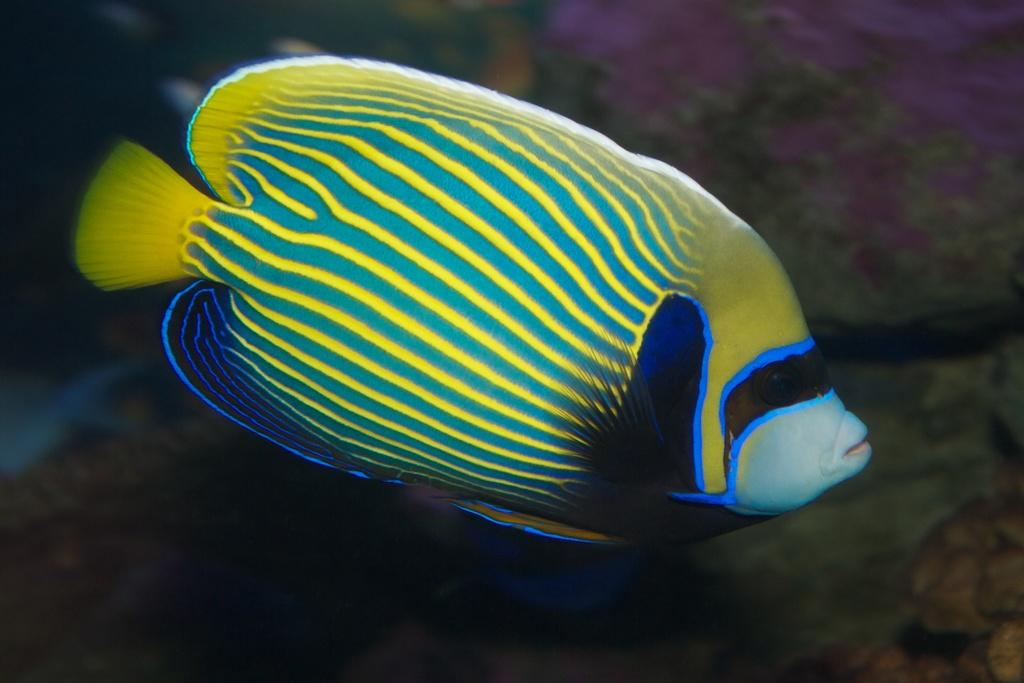What type of animal is in the image? There is a fish in the image. Where is the fish located? The fish is in the water. What type of bat can be seen flying near the fish in the image? There is no bat present in the image; it only features a fish in the water. What type of boot is visible on the fish in the image? There are no boots or any apparel on the fish in the image; it is simply a fish in the water. 